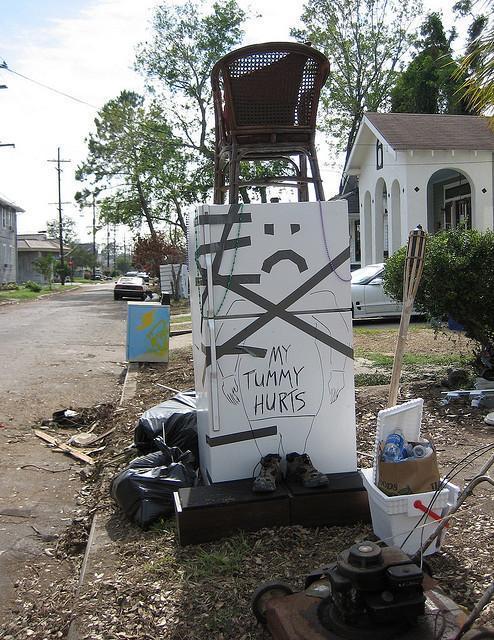How many men are in the room?
Give a very brief answer. 0. 